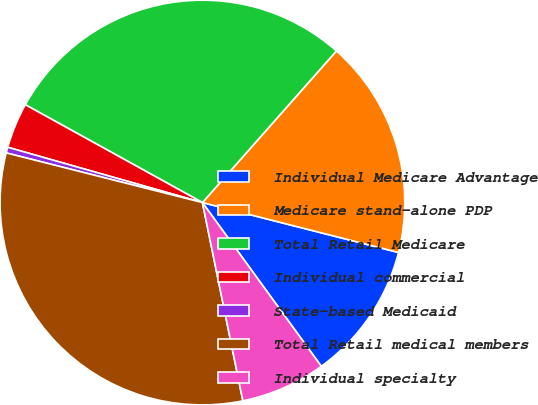<chart> <loc_0><loc_0><loc_500><loc_500><pie_chart><fcel>Individual Medicare Advantage<fcel>Medicare stand-alone PDP<fcel>Total Retail Medicare<fcel>Individual commercial<fcel>State-based Medicaid<fcel>Total Retail medical members<fcel>Individual specialty<nl><fcel>11.04%<fcel>17.45%<fcel>28.49%<fcel>3.63%<fcel>0.46%<fcel>32.15%<fcel>6.79%<nl></chart> 